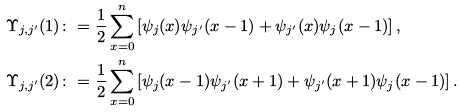Convert formula to latex. <formula><loc_0><loc_0><loc_500><loc_500>& \Upsilon _ { j , j ^ { \prime } } ( 1 ) \colon = \frac { 1 } { 2 } \sum _ { x = 0 } ^ { n } \left [ \psi _ { j } ( x ) \psi _ { j ^ { \prime } } ( x - 1 ) + \psi _ { j ^ { \prime } } ( x ) \psi _ { j } ( x - 1 ) \right ] , \\ & \Upsilon _ { j , j ^ { \prime } } ( 2 ) \colon = \frac { 1 } { 2 } \sum _ { x = 0 } ^ { n } \left [ \psi _ { j } ( x - 1 ) \psi _ { j ^ { \prime } } ( x + 1 ) + \psi _ { j ^ { \prime } } ( x + 1 ) \psi _ { j } ( x - 1 ) \right ] .</formula> 